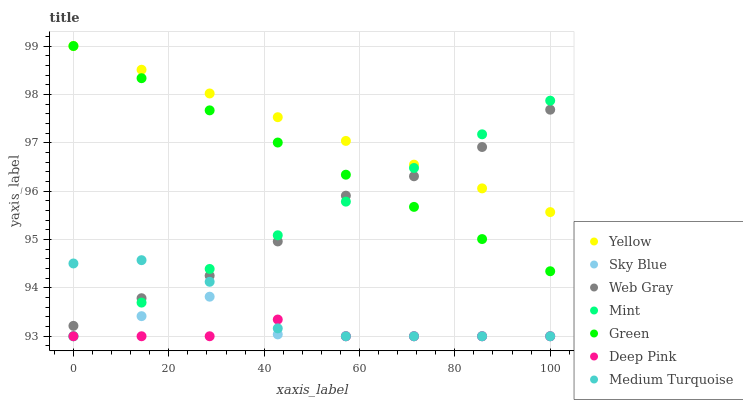Does Deep Pink have the minimum area under the curve?
Answer yes or no. Yes. Does Yellow have the maximum area under the curve?
Answer yes or no. Yes. Does Yellow have the minimum area under the curve?
Answer yes or no. No. Does Deep Pink have the maximum area under the curve?
Answer yes or no. No. Is Yellow the smoothest?
Answer yes or no. Yes. Is Medium Turquoise the roughest?
Answer yes or no. Yes. Is Deep Pink the smoothest?
Answer yes or no. No. Is Deep Pink the roughest?
Answer yes or no. No. Does Deep Pink have the lowest value?
Answer yes or no. Yes. Does Yellow have the lowest value?
Answer yes or no. No. Does Green have the highest value?
Answer yes or no. Yes. Does Deep Pink have the highest value?
Answer yes or no. No. Is Deep Pink less than Yellow?
Answer yes or no. Yes. Is Yellow greater than Sky Blue?
Answer yes or no. Yes. Does Medium Turquoise intersect Sky Blue?
Answer yes or no. Yes. Is Medium Turquoise less than Sky Blue?
Answer yes or no. No. Is Medium Turquoise greater than Sky Blue?
Answer yes or no. No. Does Deep Pink intersect Yellow?
Answer yes or no. No. 